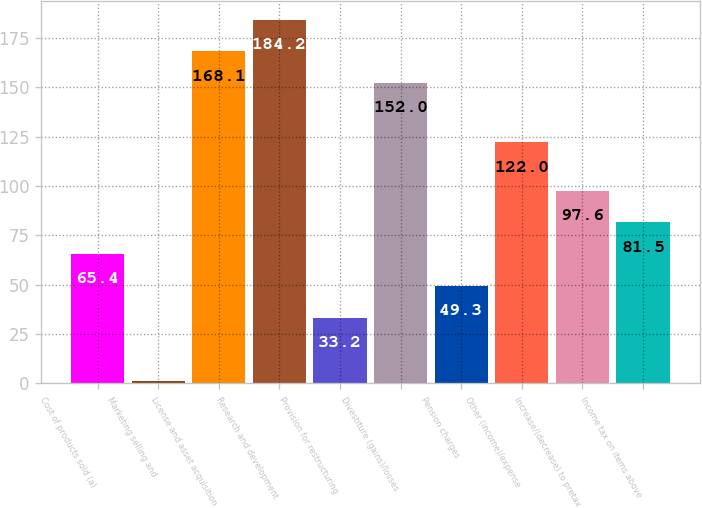Convert chart. <chart><loc_0><loc_0><loc_500><loc_500><bar_chart><fcel>Cost of products sold (a)<fcel>Marketing selling and<fcel>License and asset acquisition<fcel>Research and development<fcel>Provision for restructuring<fcel>Divestiture (gains)/losses<fcel>Pension charges<fcel>Other (income)/expense<fcel>Increase/(decrease) to pretax<fcel>Income tax on items above<nl><fcel>65.4<fcel>1<fcel>168.1<fcel>184.2<fcel>33.2<fcel>152<fcel>49.3<fcel>122<fcel>97.6<fcel>81.5<nl></chart> 